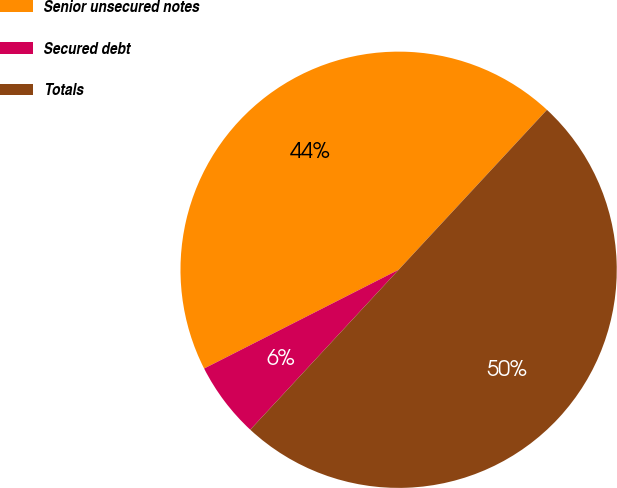Convert chart. <chart><loc_0><loc_0><loc_500><loc_500><pie_chart><fcel>Senior unsecured notes<fcel>Secured debt<fcel>Totals<nl><fcel>44.38%<fcel>5.62%<fcel>50.0%<nl></chart> 